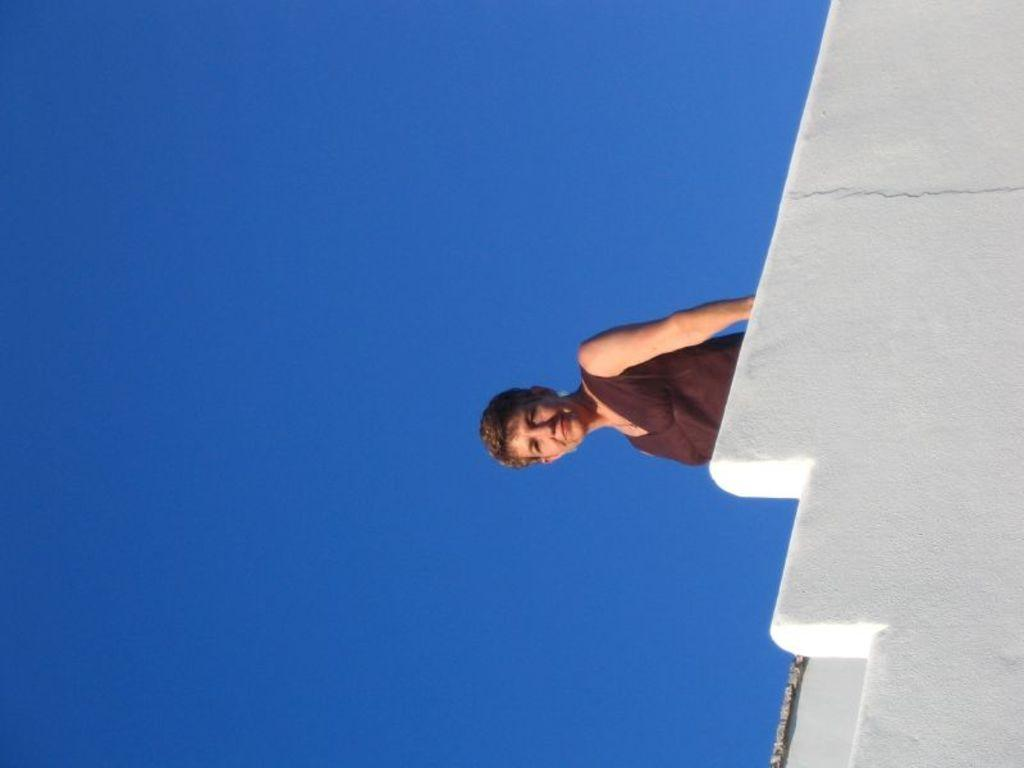What is the main subject of the picture? The main subject of the picture is a woman. What is the woman wearing in the image? The woman is wearing a brown dress. How does the woman appear in the image? The woman is stunning and smiling. What can be seen beside the woman in the image? There is a white wall beside the woman. What is visible in the background of the image? The sky is visible in the background of the image. What is the color of the sky in the image? The color of the sky is blue. What route does the woman take to reach the sea in the image? There is no sea present in the image, and therefore no route to reach it. How many letters are visible on the woman's dress in the image? There are no letters visible on the woman's dress in the image. 